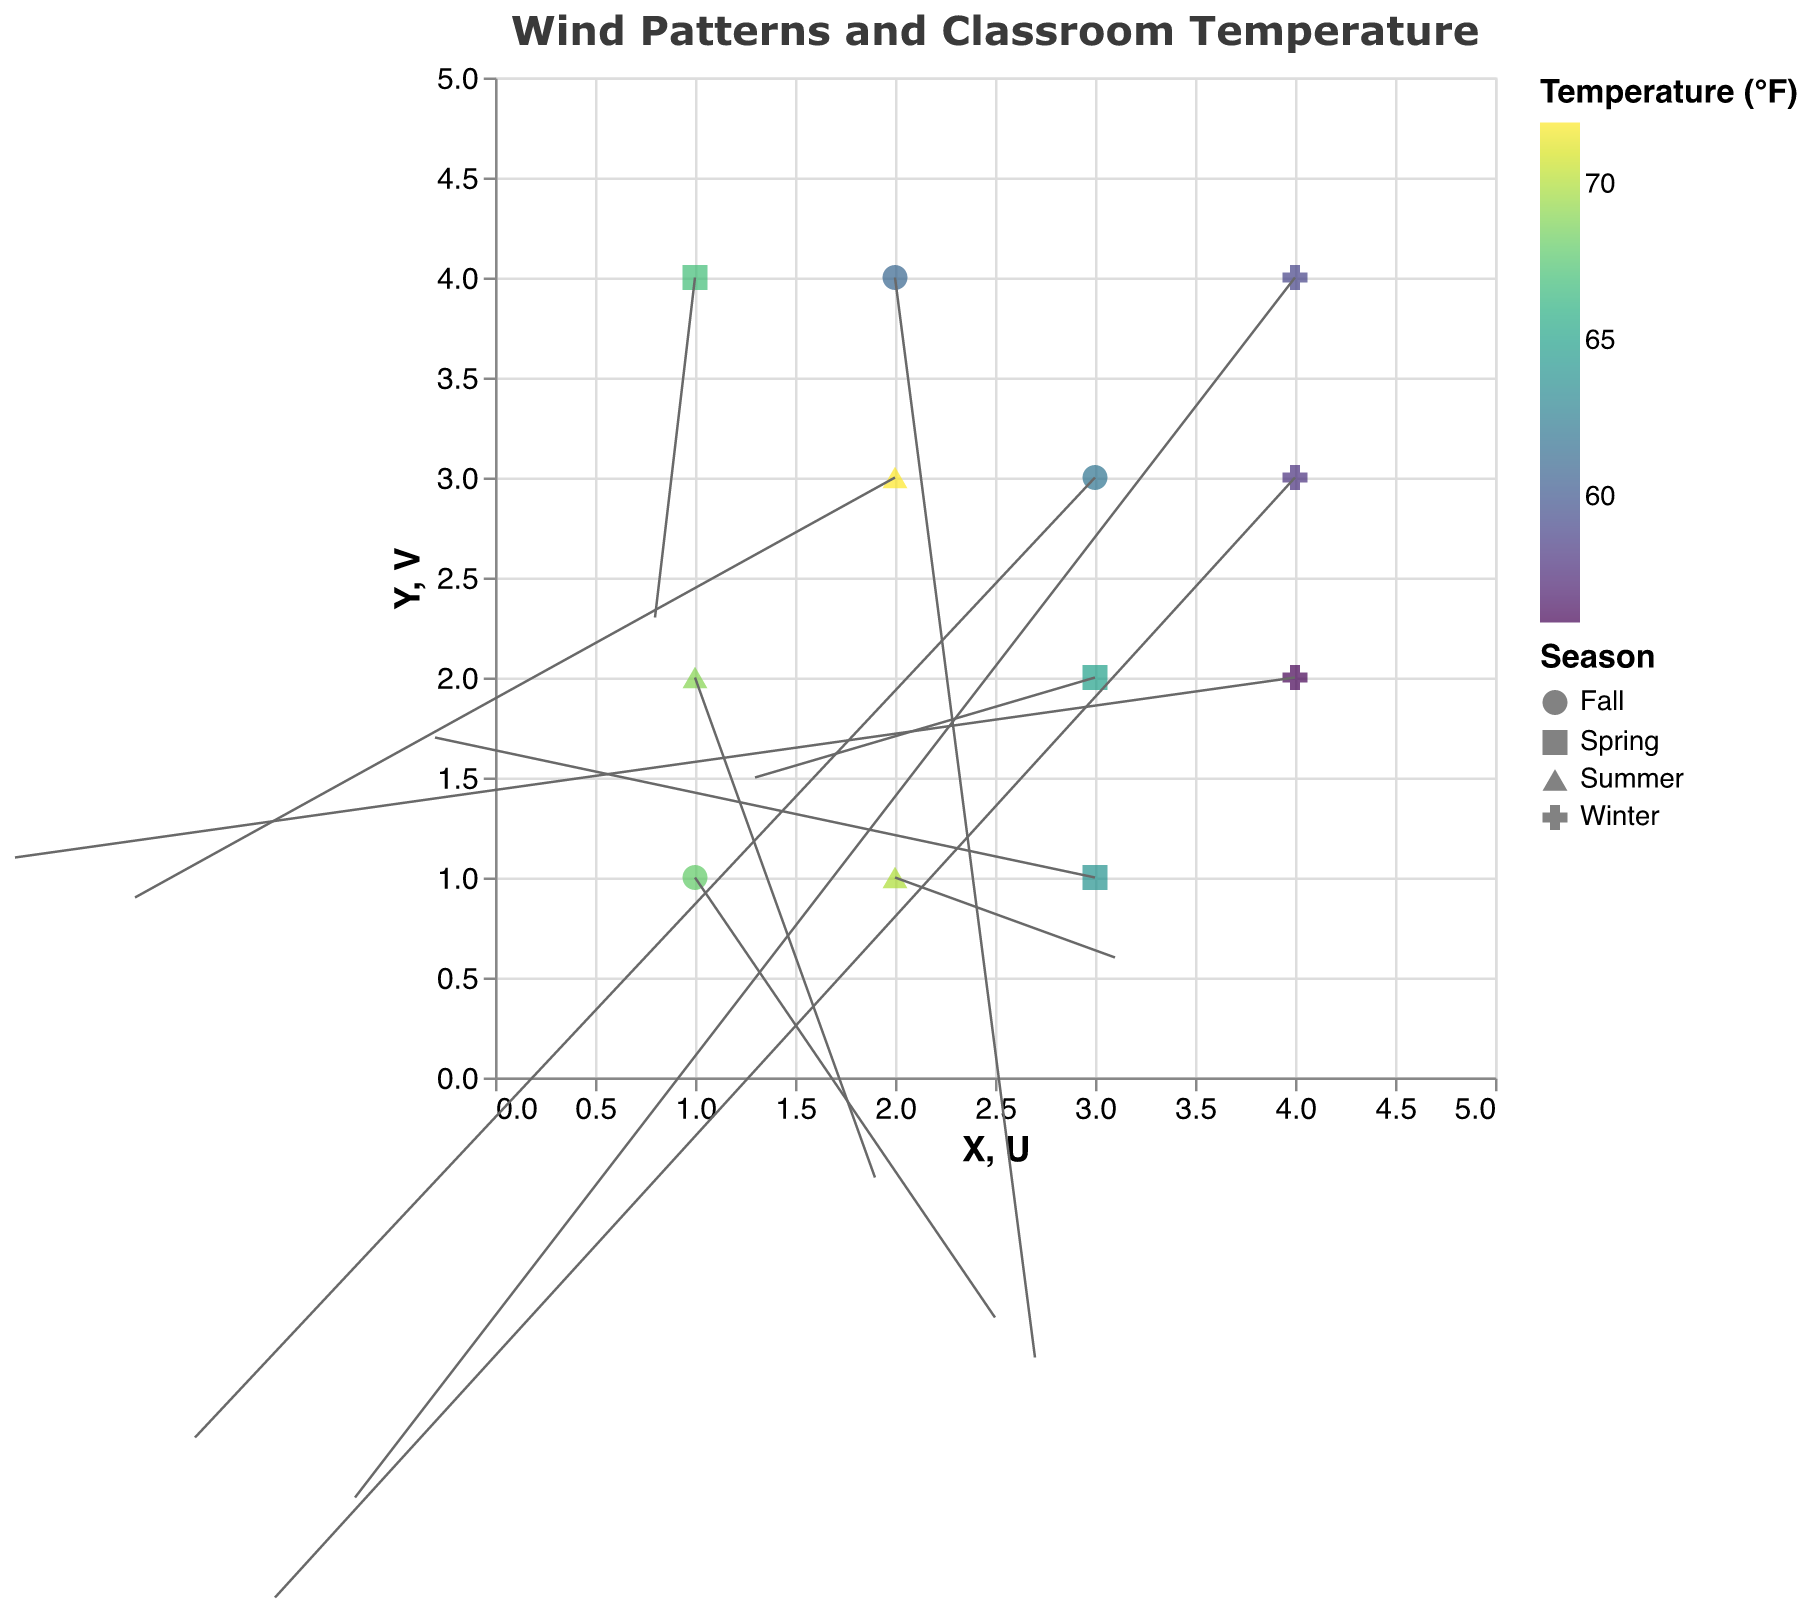What's the title of the figure? The title of the figure is typically found at the top of the chart. Here, it is "Wind Patterns and Classroom Temperature" as indicated in the title section of the provided code.
Answer: Wind Patterns and Classroom Temperature How many data points are represented in the plot? Count the total number of unique (X, Y) coordinates provided in the data section. Each data point corresponds to a unique coordinate. In this case, there are 12 data points.
Answer: 12 Which season has the lowest classroom temperature recorded in the data? Identify which season corresponds to the minimum temperature value within the list of data points. By examining the data, "Winter" has the lowest temperatures of 56, 58, and 59.
Answer: Winter Between Fall and Summer, which season experiences higher temperature readings? Compare the temperature values corresponding to "Fall" and "Summer". Fall has values of 68, 62, and 61, while Summer has values of 72, 70, and 69. Since the Summer temperatures are higher, Summer has higher temperature readings.
Answer: Summer What is the color of the data point with the highest temperature? Locate the highest temperature in the data, which is 72, and find its corresponding color. The color code scheme used is "viridis." The exact visualization will show a specific color from this palette, likely a bright yellow-green.
Answer: Bright yellow-green (viridis scheme) What direction does the wind predominantly travel in the Winter season? Examine the U and V components for Winter data points. U (horizontal component) values are -0.7, -2.4, and -1.1, indicating westward direction (negative values). V (vertical component) values are -2.1, 1.1, and -2.6, indicating a mix of upward and downward movement. Predominantly, the wind has a westward component.
Answer: Westward What is the average classroom temperature during the Spring season? Identify all temperature values for Spring, which are 65, 67, and 64. Calculate the average: (65 + 67 + 64) / 3 = 196 / 3 = 65.33°F.
Answer: 65.33°F Which data point has the highest vertical (V) component of wind, and what is its temperature? Examine the V components and identify the maximum value, 2.3 located at (1,4) during the Spring season with a temperature of 67.
Answer: 67°F Compare the wind patterns between Spring and Fall. Which season has stronger wind components? Examine the magnitudes of U and V in Spring (65, 67, 64) and Fall (68, 62, 61). Calculate the average wind speed for each season by finding the sum of the squares of U and V, then averaging. Spring averages yield slightly lower wind magnitudes.
Answer: Fall Where is the highest horizontal (U) component wind observed, and during which season? Identify the maximum U value, which is 3.1 at (2,1) occurring in Summer.
Answer: Summer 